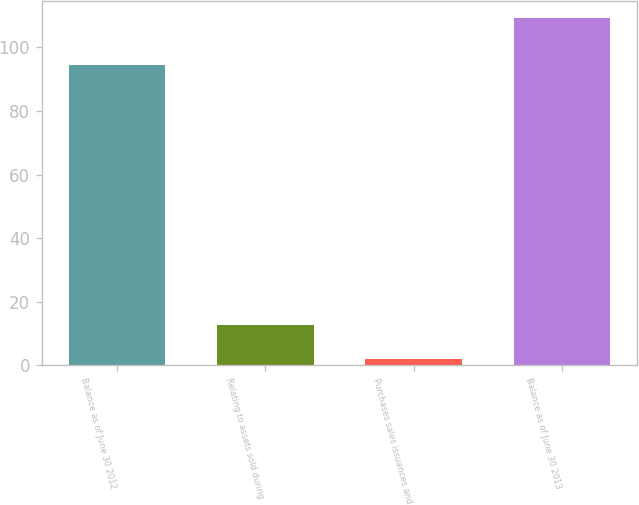Convert chart. <chart><loc_0><loc_0><loc_500><loc_500><bar_chart><fcel>Balance as of June 30 2012<fcel>Relating to assets sold during<fcel>Purchases sales issuances and<fcel>Balance as of June 30 2013<nl><fcel>94.5<fcel>12.7<fcel>1.9<fcel>109.2<nl></chart> 